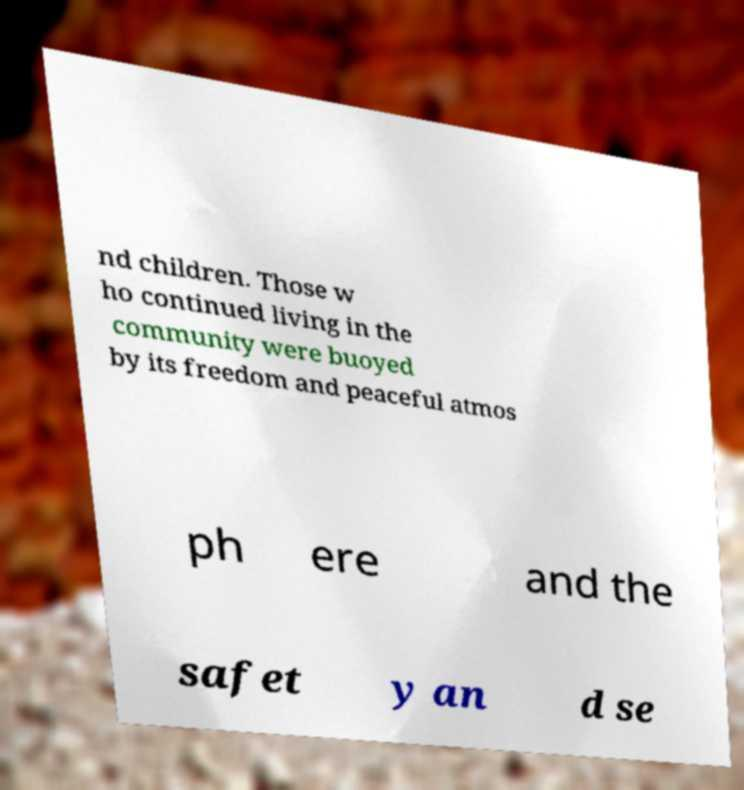Could you assist in decoding the text presented in this image and type it out clearly? nd children. Those w ho continued living in the community were buoyed by its freedom and peaceful atmos ph ere and the safet y an d se 